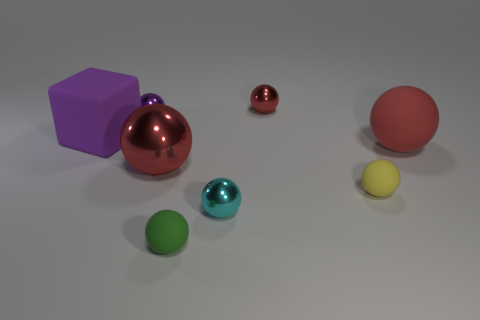Add 1 large red metal objects. How many objects exist? 9 Subtract all yellow spheres. How many spheres are left? 6 Subtract all matte spheres. How many spheres are left? 4 Subtract all spheres. How many objects are left? 1 Subtract 1 blocks. How many blocks are left? 0 Subtract all purple blocks. How many green balls are left? 1 Subtract all small yellow objects. Subtract all big rubber balls. How many objects are left? 6 Add 4 tiny green objects. How many tiny green objects are left? 5 Add 7 tiny purple metal objects. How many tiny purple metal objects exist? 8 Subtract 0 purple cylinders. How many objects are left? 8 